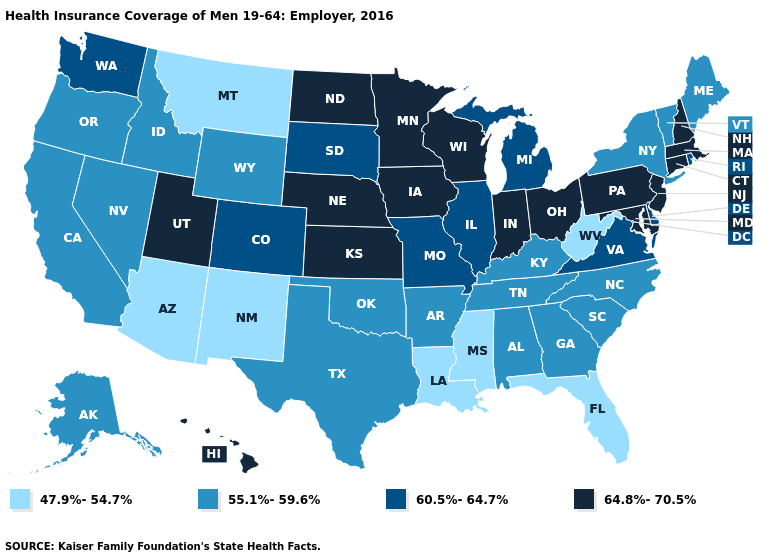What is the highest value in the USA?
Answer briefly. 64.8%-70.5%. Name the states that have a value in the range 60.5%-64.7%?
Answer briefly. Colorado, Delaware, Illinois, Michigan, Missouri, Rhode Island, South Dakota, Virginia, Washington. What is the value of Massachusetts?
Keep it brief. 64.8%-70.5%. Name the states that have a value in the range 55.1%-59.6%?
Write a very short answer. Alabama, Alaska, Arkansas, California, Georgia, Idaho, Kentucky, Maine, Nevada, New York, North Carolina, Oklahoma, Oregon, South Carolina, Tennessee, Texas, Vermont, Wyoming. Among the states that border Alabama , which have the highest value?
Quick response, please. Georgia, Tennessee. Does New Mexico have the lowest value in the USA?
Concise answer only. Yes. What is the highest value in the MidWest ?
Keep it brief. 64.8%-70.5%. Name the states that have a value in the range 60.5%-64.7%?
Write a very short answer. Colorado, Delaware, Illinois, Michigan, Missouri, Rhode Island, South Dakota, Virginia, Washington. Name the states that have a value in the range 47.9%-54.7%?
Give a very brief answer. Arizona, Florida, Louisiana, Mississippi, Montana, New Mexico, West Virginia. What is the value of Utah?
Keep it brief. 64.8%-70.5%. What is the value of Mississippi?
Give a very brief answer. 47.9%-54.7%. Which states have the lowest value in the USA?
Quick response, please. Arizona, Florida, Louisiana, Mississippi, Montana, New Mexico, West Virginia. Name the states that have a value in the range 55.1%-59.6%?
Concise answer only. Alabama, Alaska, Arkansas, California, Georgia, Idaho, Kentucky, Maine, Nevada, New York, North Carolina, Oklahoma, Oregon, South Carolina, Tennessee, Texas, Vermont, Wyoming. Name the states that have a value in the range 64.8%-70.5%?
Keep it brief. Connecticut, Hawaii, Indiana, Iowa, Kansas, Maryland, Massachusetts, Minnesota, Nebraska, New Hampshire, New Jersey, North Dakota, Ohio, Pennsylvania, Utah, Wisconsin. Does the first symbol in the legend represent the smallest category?
Quick response, please. Yes. 